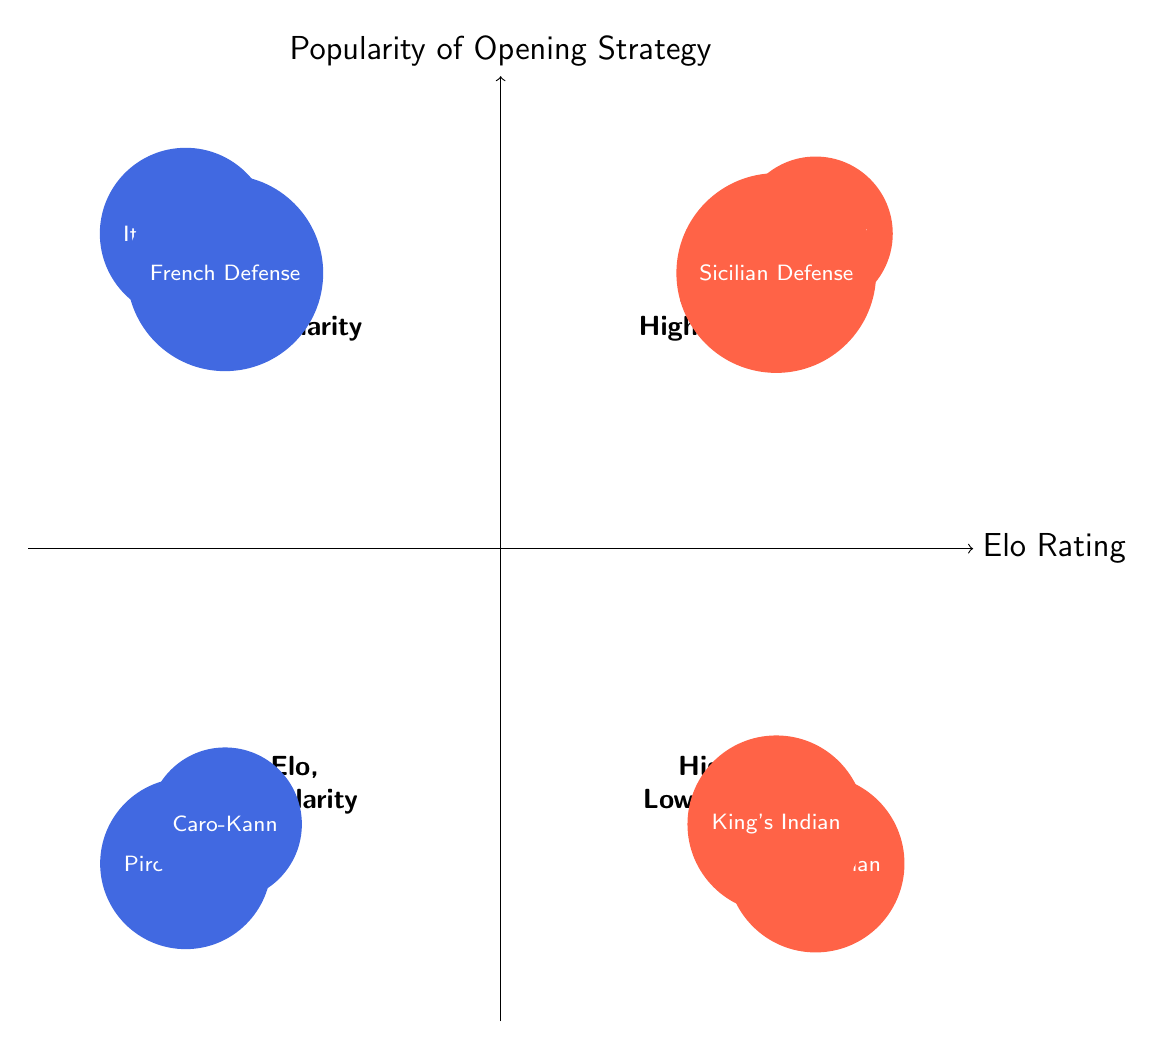What are the two opening strategies in the High Elo, High Popularity quadrant? The High Elo, High Popularity quadrant is located in the top right section of the diagram. In this section, the strategies listed are "Ruy López" and "Sicilian Defense."
Answer: Ruy López, Sicilian Defense How many strategies are present in the Low Elo, Low Popularity quadrant? The Low Elo, Low Popularity quadrant is located in the bottom left section of the diagram. It contains two strategies listed: "Pirc Defense" and "Caro-Kann Defense." Thus, the total is two strategies.
Answer: 2 Which opening strategy is popular among low Elo players? The Low Elo, High Popularity quadrant is where strategies popular among low Elo players are found. The strategies listed here are "Italian Game" and "French Defense." Therefore, they are the strategies popular among low Elo players.
Answer: Italian Game, French Defense Which quadrant contains the "Nimzo-Indian Defense"? The "Nimzo-Indian Defense" is located in the High Elo, Low Popularity quadrant, which is in the lower right section of the diagram. It is one of the strategies listed in that quadrant.
Answer: High Elo, Low Popularity Which quadrant has no high popularity strategies? The quadrants with no high popularity strategies are the Low Elo, Low Popularity quadrant and the High Elo, Low Popularity quadrant. The former contains "Pirc Defense" and "Caro-Kann Defense," while the latter has "Nimzo-Indian Defense" and "King's Indian Defense." Thus, both quadrants lack high popularity strategies.
Answer: Low Elo, Low Popularity; High Elo, Low Popularity What is the relationship between "Elo Rating" and "Popularity of Opening Strategy"? The x-axis represents the "Elo Rating," and the y-axis represents the "Popularity of Opening Strategy." High ratings correlate with a higher likelihood of using widely popular strategies, as shown in the High Elo, High Popularity quadrant. Conversely, strategies with low popularity relate to lower Elo ratings.
Answer: Positive correlation What is the highest-ranked strategy listed in the diagram? The "Ruy López" is the highest-ranked strategy in the diagram, as it is in the High Elo, High Popularity quadrant, indicating it has both high popularity and is favored by high Elo players.
Answer: Ruy López Which quadrant has "French Defense" and what does that imply about player ratings? The "French Defense" is in the Low Elo, High Popularity quadrant, which implies that it is a strategy frequently used by players with lower Elo ratings. This suggests that while it is popular, it may not be associated with high-level play.
Answer: Low Elo, High Popularity 